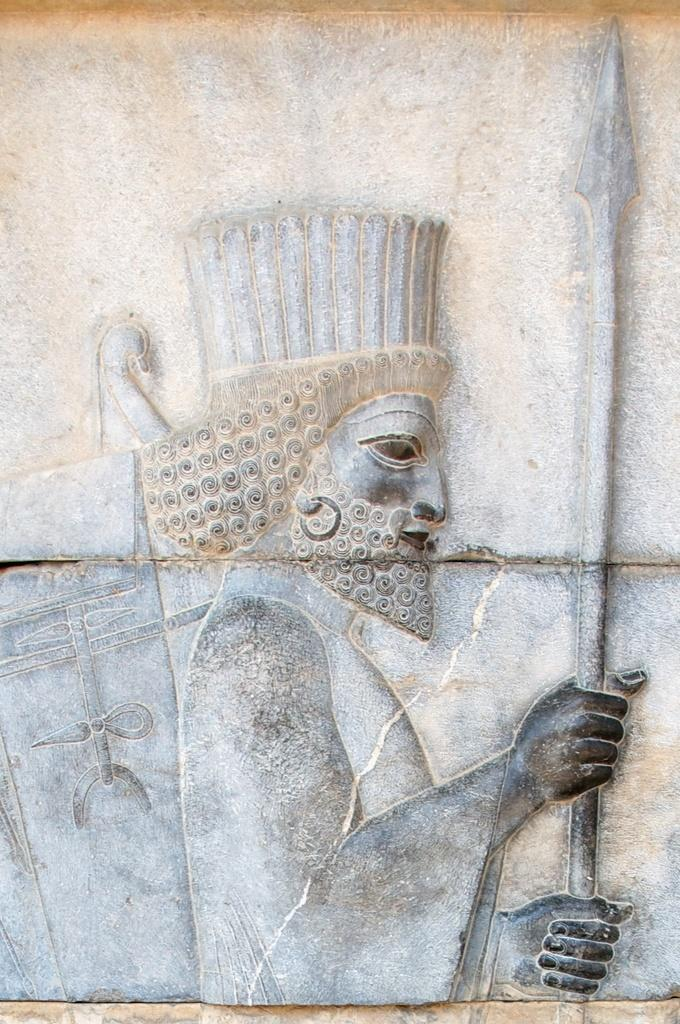What can be seen on the wall in the image? There is carving on the wall in the image. What type of silverware is depicted in the carving on the wall? There is no silverware depicted in the carving on the wall; the fact only mentions carving, not any specific objects or designs. 